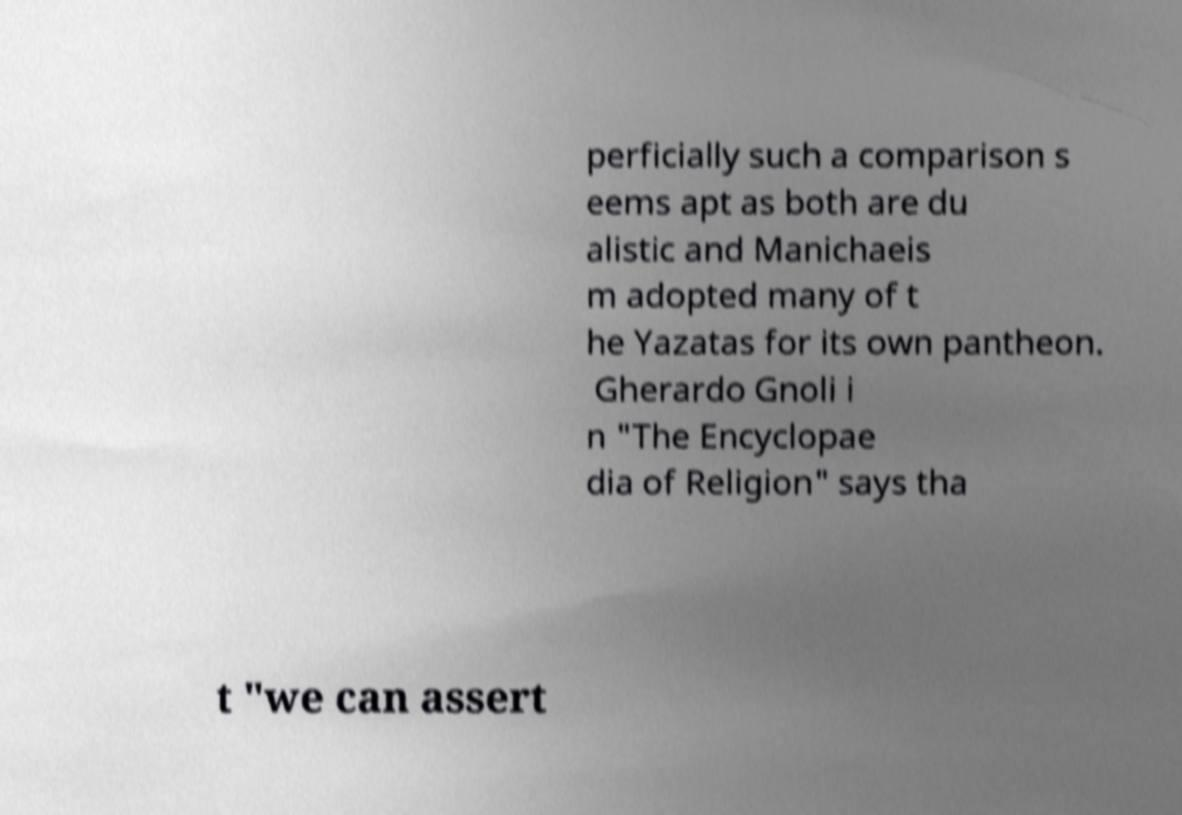Please read and relay the text visible in this image. What does it say? perficially such a comparison s eems apt as both are du alistic and Manichaeis m adopted many of t he Yazatas for its own pantheon. Gherardo Gnoli i n "The Encyclopae dia of Religion" says tha t "we can assert 